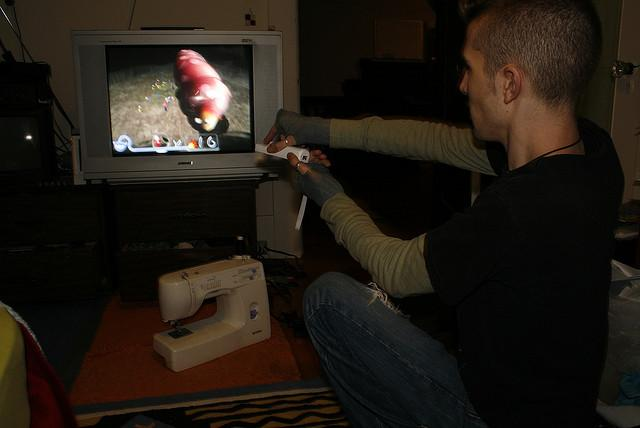The item on the floor looks like what?

Choices:
A) hammer
B) toad
C) baby
D) sewing machine sewing machine 